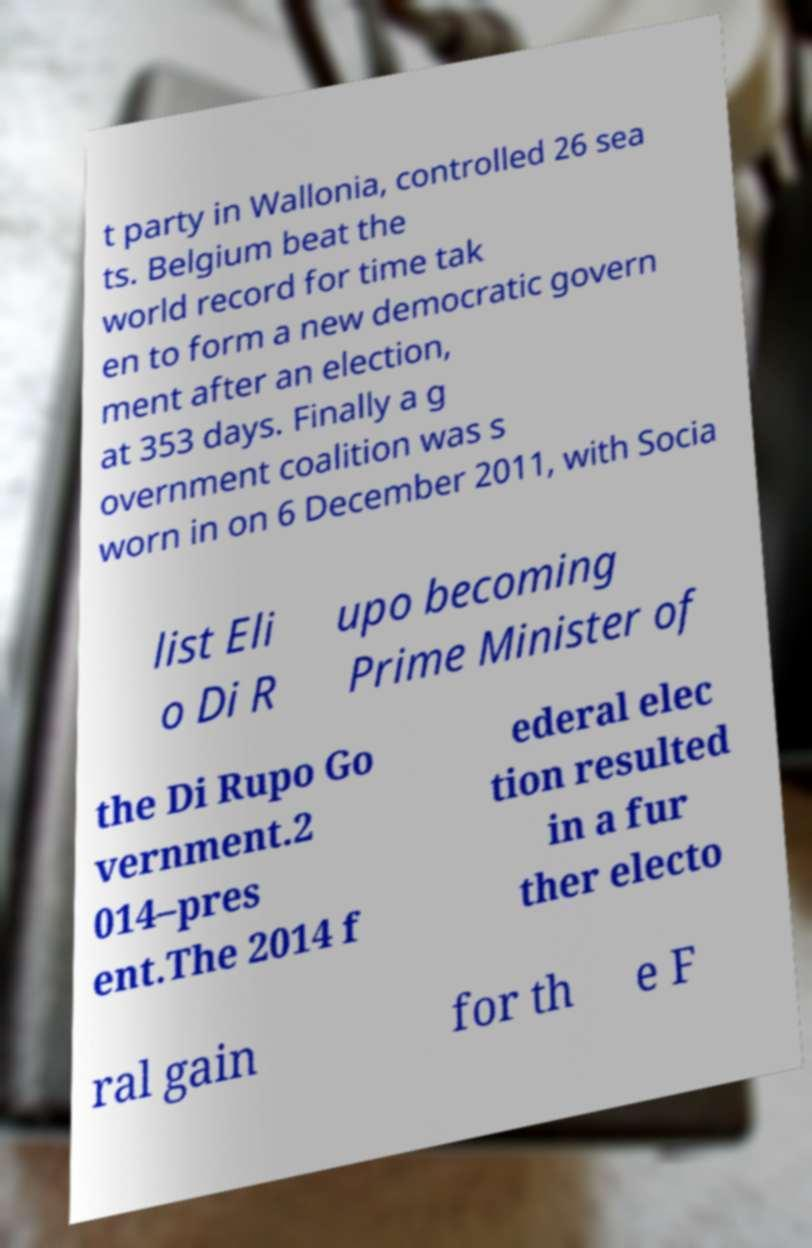For documentation purposes, I need the text within this image transcribed. Could you provide that? t party in Wallonia, controlled 26 sea ts. Belgium beat the world record for time tak en to form a new democratic govern ment after an election, at 353 days. Finally a g overnment coalition was s worn in on 6 December 2011, with Socia list Eli o Di R upo becoming Prime Minister of the Di Rupo Go vernment.2 014–pres ent.The 2014 f ederal elec tion resulted in a fur ther electo ral gain for th e F 